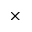Convert formula to latex. <formula><loc_0><loc_0><loc_500><loc_500>\times</formula> 